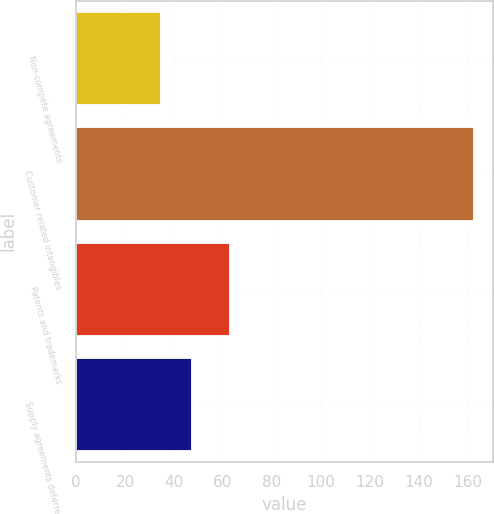Convert chart to OTSL. <chart><loc_0><loc_0><loc_500><loc_500><bar_chart><fcel>Non-compete agreements<fcel>Customer related intangibles<fcel>Patents and trademarks<fcel>Supply agreements deferred<nl><fcel>34.2<fcel>162.3<fcel>62.4<fcel>47.01<nl></chart> 